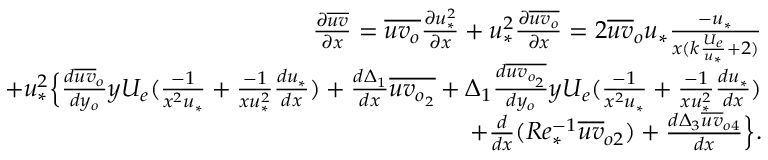Convert formula to latex. <formula><loc_0><loc_0><loc_500><loc_500>\begin{array} { r } { \frac { \partial \overline { u v } } { \partial x } = \overline { { u v _ { o } } } \frac { \partial u _ { * } ^ { 2 } } { \partial x } + u _ { * } ^ { 2 } \frac { \partial \overline { { u v _ { o } } } } { \partial x } = 2 \overline { u v } _ { o } u _ { * } \frac { - u _ { * } } { x ( { k \frac { U _ { e } } { u _ { * } } + 2 } ) } } \\ { + u _ { * } ^ { 2 } \left \{ \frac { d \overline { u v } _ { o } } { d y _ { o } } y U _ { e } ( \frac { - 1 } { x ^ { 2 } u _ { * } } + \frac { - 1 } { x u _ { * } ^ { 2 } } \frac { d u _ { * } } { d x } ) + \frac { d \Delta _ { 1 } } { d x } \overline { { u v _ { o _ { 2 } } } } + \Delta _ { 1 } { \frac { d \overline { { u v _ { o _ { 2 } } } } } { d y _ { o } } y U _ { e } ( \frac { - 1 } { x ^ { 2 } u _ { * } } + \frac { - 1 } { x u _ { * } ^ { 2 } } \frac { d u _ { * } } { d x } ) } } \\ { + \frac { d } { d x } ( R e _ { * } ^ { - 1 } \overline { u v } _ { o 2 } ) + \frac { d \Delta _ { 3 } \overline { u v } _ { o 4 } } { d x } \right \} . } \end{array}</formula> 